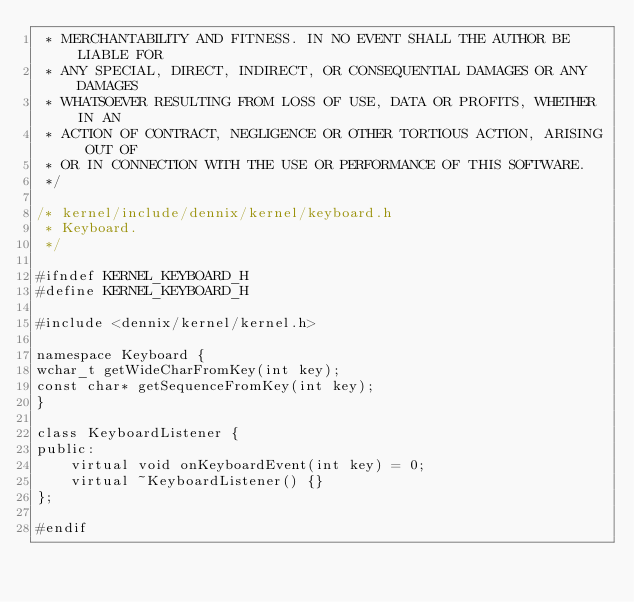Convert code to text. <code><loc_0><loc_0><loc_500><loc_500><_C_> * MERCHANTABILITY AND FITNESS. IN NO EVENT SHALL THE AUTHOR BE LIABLE FOR
 * ANY SPECIAL, DIRECT, INDIRECT, OR CONSEQUENTIAL DAMAGES OR ANY DAMAGES
 * WHATSOEVER RESULTING FROM LOSS OF USE, DATA OR PROFITS, WHETHER IN AN
 * ACTION OF CONTRACT, NEGLIGENCE OR OTHER TORTIOUS ACTION, ARISING OUT OF
 * OR IN CONNECTION WITH THE USE OR PERFORMANCE OF THIS SOFTWARE.
 */

/* kernel/include/dennix/kernel/keyboard.h
 * Keyboard.
 */

#ifndef KERNEL_KEYBOARD_H
#define KERNEL_KEYBOARD_H

#include <dennix/kernel/kernel.h>

namespace Keyboard {
wchar_t getWideCharFromKey(int key);
const char* getSequenceFromKey(int key);
}

class KeyboardListener {
public:
    virtual void onKeyboardEvent(int key) = 0;
    virtual ~KeyboardListener() {}
};

#endif
</code> 